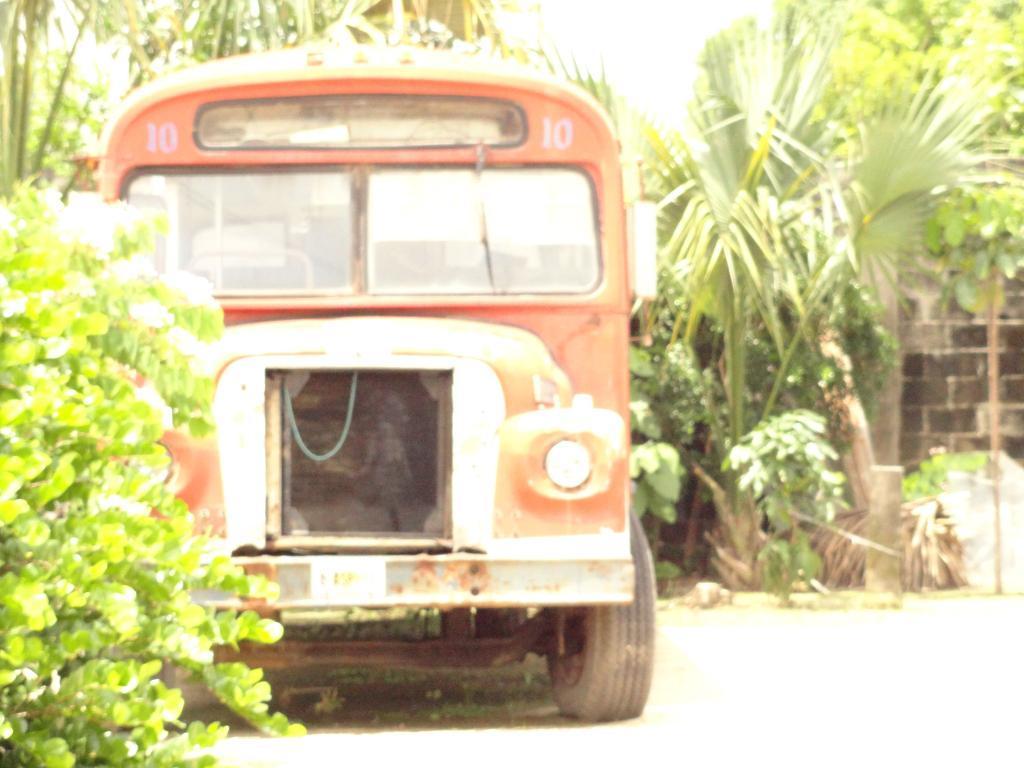How would you summarize this image in a sentence or two? Here in this picture we can see a bus present on the road and we can see plants and trees covered over there. 